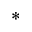<formula> <loc_0><loc_0><loc_500><loc_500>^ { * }</formula> 